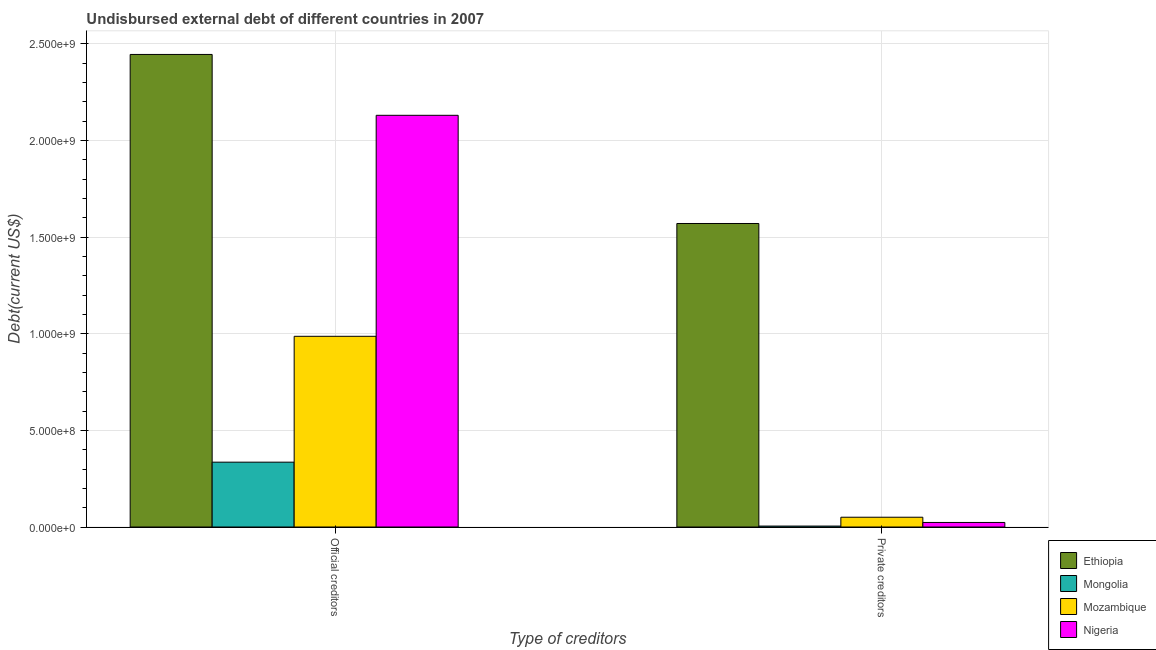How many different coloured bars are there?
Your answer should be very brief. 4. How many groups of bars are there?
Provide a short and direct response. 2. Are the number of bars per tick equal to the number of legend labels?
Provide a succinct answer. Yes. How many bars are there on the 1st tick from the right?
Your response must be concise. 4. What is the label of the 2nd group of bars from the left?
Offer a very short reply. Private creditors. What is the undisbursed external debt of official creditors in Nigeria?
Provide a succinct answer. 2.13e+09. Across all countries, what is the maximum undisbursed external debt of private creditors?
Give a very brief answer. 1.57e+09. Across all countries, what is the minimum undisbursed external debt of official creditors?
Your answer should be very brief. 3.36e+08. In which country was the undisbursed external debt of official creditors maximum?
Your answer should be compact. Ethiopia. In which country was the undisbursed external debt of private creditors minimum?
Your answer should be very brief. Mongolia. What is the total undisbursed external debt of private creditors in the graph?
Make the answer very short. 1.65e+09. What is the difference between the undisbursed external debt of private creditors in Mongolia and that in Ethiopia?
Your answer should be compact. -1.57e+09. What is the difference between the undisbursed external debt of private creditors in Ethiopia and the undisbursed external debt of official creditors in Nigeria?
Ensure brevity in your answer.  -5.60e+08. What is the average undisbursed external debt of private creditors per country?
Keep it short and to the point. 4.12e+08. What is the difference between the undisbursed external debt of private creditors and undisbursed external debt of official creditors in Ethiopia?
Your answer should be very brief. -8.75e+08. What is the ratio of the undisbursed external debt of official creditors in Nigeria to that in Ethiopia?
Your response must be concise. 0.87. What does the 3rd bar from the left in Private creditors represents?
Provide a short and direct response. Mozambique. What does the 1st bar from the right in Private creditors represents?
Offer a terse response. Nigeria. Are all the bars in the graph horizontal?
Make the answer very short. No. How many countries are there in the graph?
Provide a short and direct response. 4. Are the values on the major ticks of Y-axis written in scientific E-notation?
Make the answer very short. Yes. Does the graph contain any zero values?
Your answer should be very brief. No. Does the graph contain grids?
Give a very brief answer. Yes. Where does the legend appear in the graph?
Your response must be concise. Bottom right. How many legend labels are there?
Offer a terse response. 4. How are the legend labels stacked?
Your answer should be very brief. Vertical. What is the title of the graph?
Make the answer very short. Undisbursed external debt of different countries in 2007. What is the label or title of the X-axis?
Provide a succinct answer. Type of creditors. What is the label or title of the Y-axis?
Your response must be concise. Debt(current US$). What is the Debt(current US$) in Ethiopia in Official creditors?
Offer a terse response. 2.45e+09. What is the Debt(current US$) of Mongolia in Official creditors?
Offer a terse response. 3.36e+08. What is the Debt(current US$) in Mozambique in Official creditors?
Make the answer very short. 9.87e+08. What is the Debt(current US$) of Nigeria in Official creditors?
Make the answer very short. 2.13e+09. What is the Debt(current US$) in Ethiopia in Private creditors?
Keep it short and to the point. 1.57e+09. What is the Debt(current US$) of Mongolia in Private creditors?
Offer a terse response. 4.90e+06. What is the Debt(current US$) of Mozambique in Private creditors?
Provide a succinct answer. 5.06e+07. What is the Debt(current US$) in Nigeria in Private creditors?
Ensure brevity in your answer.  2.36e+07. Across all Type of creditors, what is the maximum Debt(current US$) in Ethiopia?
Your answer should be compact. 2.45e+09. Across all Type of creditors, what is the maximum Debt(current US$) of Mongolia?
Offer a very short reply. 3.36e+08. Across all Type of creditors, what is the maximum Debt(current US$) of Mozambique?
Your response must be concise. 9.87e+08. Across all Type of creditors, what is the maximum Debt(current US$) in Nigeria?
Ensure brevity in your answer.  2.13e+09. Across all Type of creditors, what is the minimum Debt(current US$) in Ethiopia?
Your answer should be compact. 1.57e+09. Across all Type of creditors, what is the minimum Debt(current US$) of Mongolia?
Provide a short and direct response. 4.90e+06. Across all Type of creditors, what is the minimum Debt(current US$) of Mozambique?
Ensure brevity in your answer.  5.06e+07. Across all Type of creditors, what is the minimum Debt(current US$) of Nigeria?
Make the answer very short. 2.36e+07. What is the total Debt(current US$) in Ethiopia in the graph?
Give a very brief answer. 4.02e+09. What is the total Debt(current US$) of Mongolia in the graph?
Your response must be concise. 3.40e+08. What is the total Debt(current US$) of Mozambique in the graph?
Your answer should be compact. 1.04e+09. What is the total Debt(current US$) in Nigeria in the graph?
Offer a terse response. 2.15e+09. What is the difference between the Debt(current US$) of Ethiopia in Official creditors and that in Private creditors?
Ensure brevity in your answer.  8.75e+08. What is the difference between the Debt(current US$) of Mongolia in Official creditors and that in Private creditors?
Provide a succinct answer. 3.31e+08. What is the difference between the Debt(current US$) of Mozambique in Official creditors and that in Private creditors?
Ensure brevity in your answer.  9.36e+08. What is the difference between the Debt(current US$) of Nigeria in Official creditors and that in Private creditors?
Offer a very short reply. 2.11e+09. What is the difference between the Debt(current US$) of Ethiopia in Official creditors and the Debt(current US$) of Mongolia in Private creditors?
Keep it short and to the point. 2.44e+09. What is the difference between the Debt(current US$) of Ethiopia in Official creditors and the Debt(current US$) of Mozambique in Private creditors?
Your answer should be very brief. 2.39e+09. What is the difference between the Debt(current US$) in Ethiopia in Official creditors and the Debt(current US$) in Nigeria in Private creditors?
Offer a very short reply. 2.42e+09. What is the difference between the Debt(current US$) of Mongolia in Official creditors and the Debt(current US$) of Mozambique in Private creditors?
Provide a short and direct response. 2.85e+08. What is the difference between the Debt(current US$) in Mongolia in Official creditors and the Debt(current US$) in Nigeria in Private creditors?
Provide a succinct answer. 3.12e+08. What is the difference between the Debt(current US$) in Mozambique in Official creditors and the Debt(current US$) in Nigeria in Private creditors?
Offer a very short reply. 9.63e+08. What is the average Debt(current US$) of Ethiopia per Type of creditors?
Provide a short and direct response. 2.01e+09. What is the average Debt(current US$) in Mongolia per Type of creditors?
Your answer should be compact. 1.70e+08. What is the average Debt(current US$) of Mozambique per Type of creditors?
Your answer should be very brief. 5.19e+08. What is the average Debt(current US$) of Nigeria per Type of creditors?
Your answer should be compact. 1.08e+09. What is the difference between the Debt(current US$) of Ethiopia and Debt(current US$) of Mongolia in Official creditors?
Your response must be concise. 2.11e+09. What is the difference between the Debt(current US$) of Ethiopia and Debt(current US$) of Mozambique in Official creditors?
Make the answer very short. 1.46e+09. What is the difference between the Debt(current US$) of Ethiopia and Debt(current US$) of Nigeria in Official creditors?
Provide a succinct answer. 3.15e+08. What is the difference between the Debt(current US$) in Mongolia and Debt(current US$) in Mozambique in Official creditors?
Keep it short and to the point. -6.51e+08. What is the difference between the Debt(current US$) in Mongolia and Debt(current US$) in Nigeria in Official creditors?
Your response must be concise. -1.80e+09. What is the difference between the Debt(current US$) in Mozambique and Debt(current US$) in Nigeria in Official creditors?
Provide a short and direct response. -1.14e+09. What is the difference between the Debt(current US$) in Ethiopia and Debt(current US$) in Mongolia in Private creditors?
Give a very brief answer. 1.57e+09. What is the difference between the Debt(current US$) of Ethiopia and Debt(current US$) of Mozambique in Private creditors?
Ensure brevity in your answer.  1.52e+09. What is the difference between the Debt(current US$) in Ethiopia and Debt(current US$) in Nigeria in Private creditors?
Provide a succinct answer. 1.55e+09. What is the difference between the Debt(current US$) of Mongolia and Debt(current US$) of Mozambique in Private creditors?
Your answer should be compact. -4.57e+07. What is the difference between the Debt(current US$) of Mongolia and Debt(current US$) of Nigeria in Private creditors?
Provide a short and direct response. -1.87e+07. What is the difference between the Debt(current US$) of Mozambique and Debt(current US$) of Nigeria in Private creditors?
Offer a terse response. 2.71e+07. What is the ratio of the Debt(current US$) in Ethiopia in Official creditors to that in Private creditors?
Your answer should be compact. 1.56. What is the ratio of the Debt(current US$) of Mongolia in Official creditors to that in Private creditors?
Keep it short and to the point. 68.48. What is the ratio of the Debt(current US$) of Mozambique in Official creditors to that in Private creditors?
Your response must be concise. 19.49. What is the ratio of the Debt(current US$) in Nigeria in Official creditors to that in Private creditors?
Offer a terse response. 90.42. What is the difference between the highest and the second highest Debt(current US$) in Ethiopia?
Offer a very short reply. 8.75e+08. What is the difference between the highest and the second highest Debt(current US$) of Mongolia?
Offer a very short reply. 3.31e+08. What is the difference between the highest and the second highest Debt(current US$) of Mozambique?
Your answer should be very brief. 9.36e+08. What is the difference between the highest and the second highest Debt(current US$) of Nigeria?
Your answer should be very brief. 2.11e+09. What is the difference between the highest and the lowest Debt(current US$) in Ethiopia?
Provide a succinct answer. 8.75e+08. What is the difference between the highest and the lowest Debt(current US$) in Mongolia?
Keep it short and to the point. 3.31e+08. What is the difference between the highest and the lowest Debt(current US$) of Mozambique?
Your answer should be compact. 9.36e+08. What is the difference between the highest and the lowest Debt(current US$) in Nigeria?
Your response must be concise. 2.11e+09. 